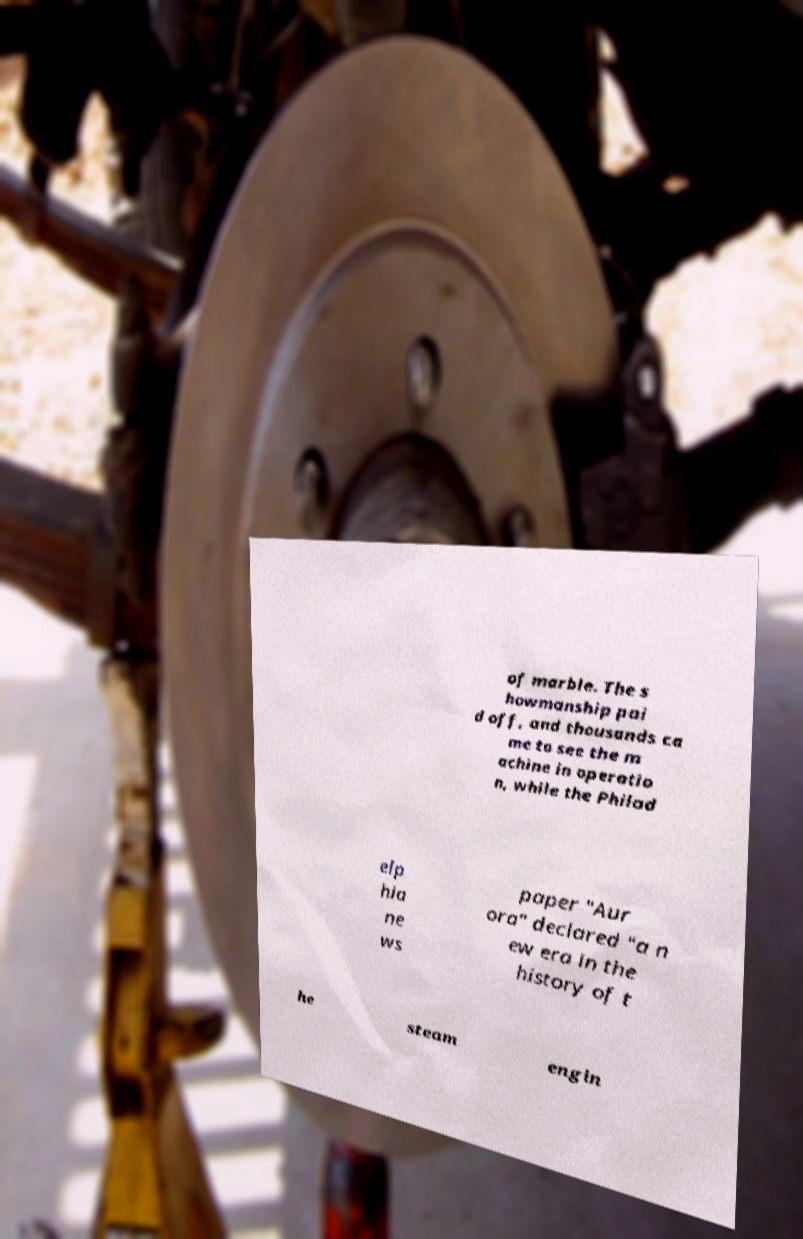Can you read and provide the text displayed in the image?This photo seems to have some interesting text. Can you extract and type it out for me? of marble. The s howmanship pai d off, and thousands ca me to see the m achine in operatio n, while the Philad elp hia ne ws paper "Aur ora" declared "a n ew era in the history of t he steam engin 